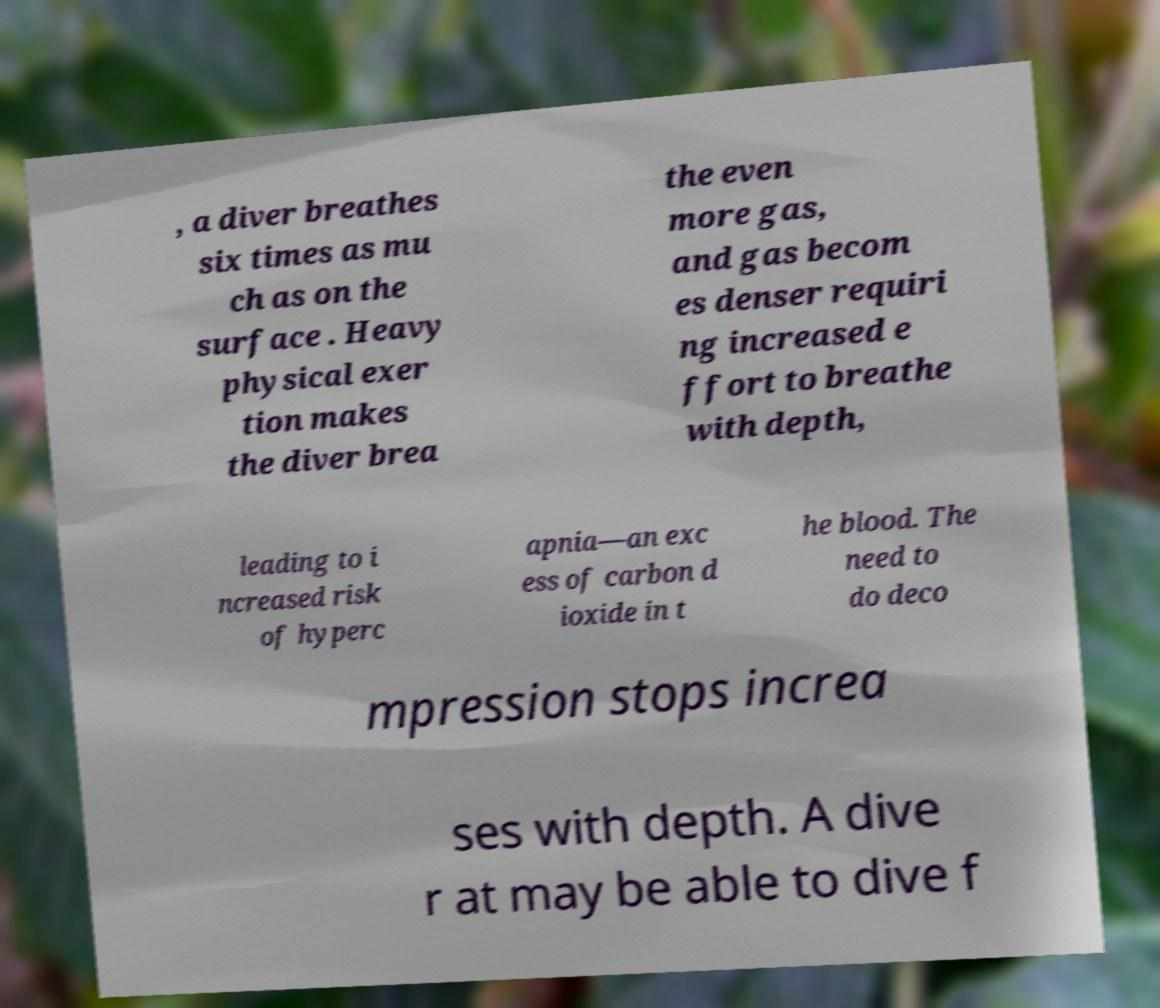Could you extract and type out the text from this image? , a diver breathes six times as mu ch as on the surface . Heavy physical exer tion makes the diver brea the even more gas, and gas becom es denser requiri ng increased e ffort to breathe with depth, leading to i ncreased risk of hyperc apnia—an exc ess of carbon d ioxide in t he blood. The need to do deco mpression stops increa ses with depth. A dive r at may be able to dive f 